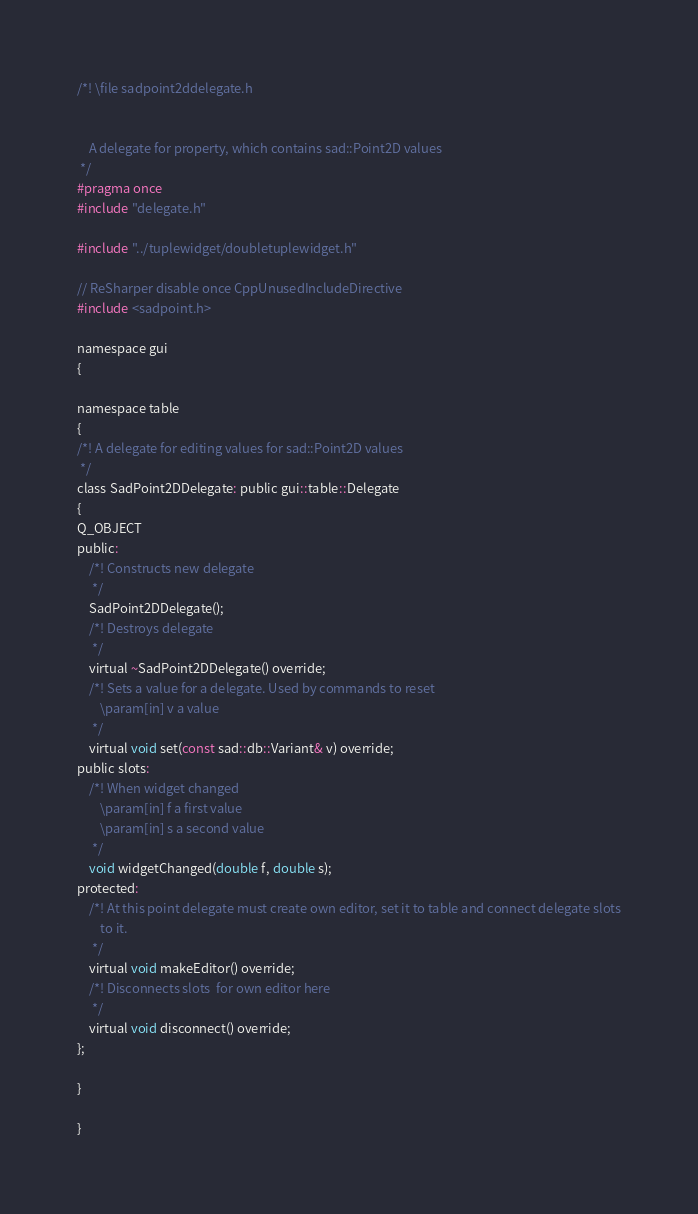Convert code to text. <code><loc_0><loc_0><loc_500><loc_500><_C_>/*! \file sadpoint2ddelegate.h
    

    A delegate for property, which contains sad::Point2D values
 */
#pragma once
#include "delegate.h"

#include "../tuplewidget/doubletuplewidget.h"

// ReSharper disable once CppUnusedIncludeDirective
#include <sadpoint.h>

namespace gui
{
    
namespace table
{
/*! A delegate for editing values for sad::Point2D values
 */
class SadPoint2DDelegate: public gui::table::Delegate
{
Q_OBJECT
public:
    /*! Constructs new delegate
     */
    SadPoint2DDelegate();
    /*! Destroys delegate
     */
    virtual ~SadPoint2DDelegate() override;
    /*! Sets a value for a delegate. Used by commands to reset
        \param[in] v a value
     */
    virtual void set(const sad::db::Variant& v) override;
public slots:
    /*! When widget changed
        \param[in] f a first value
        \param[in] s a second value
     */
    void widgetChanged(double f, double s);
protected:
    /*! At this point delegate must create own editor, set it to table and connect delegate slots
        to it.
     */
    virtual void makeEditor() override;
    /*! Disconnects slots  for own editor here
     */ 
    virtual void disconnect() override;
};

}

}
</code> 